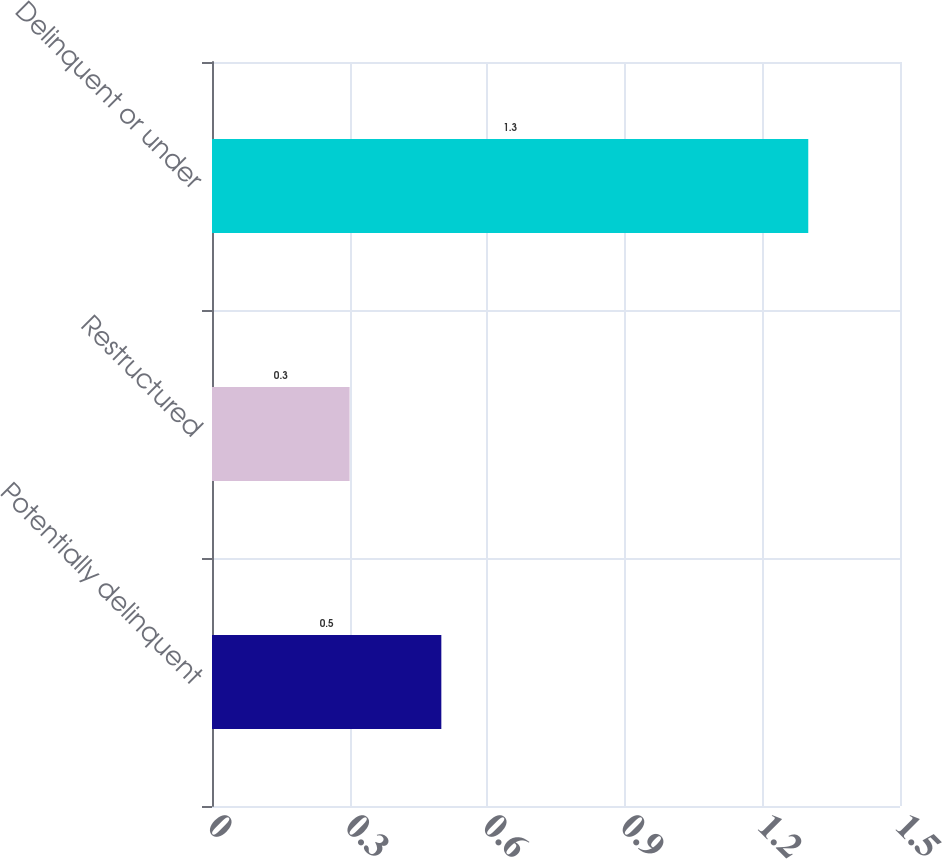Convert chart to OTSL. <chart><loc_0><loc_0><loc_500><loc_500><bar_chart><fcel>Potentially delinquent<fcel>Restructured<fcel>Delinquent or under<nl><fcel>0.5<fcel>0.3<fcel>1.3<nl></chart> 